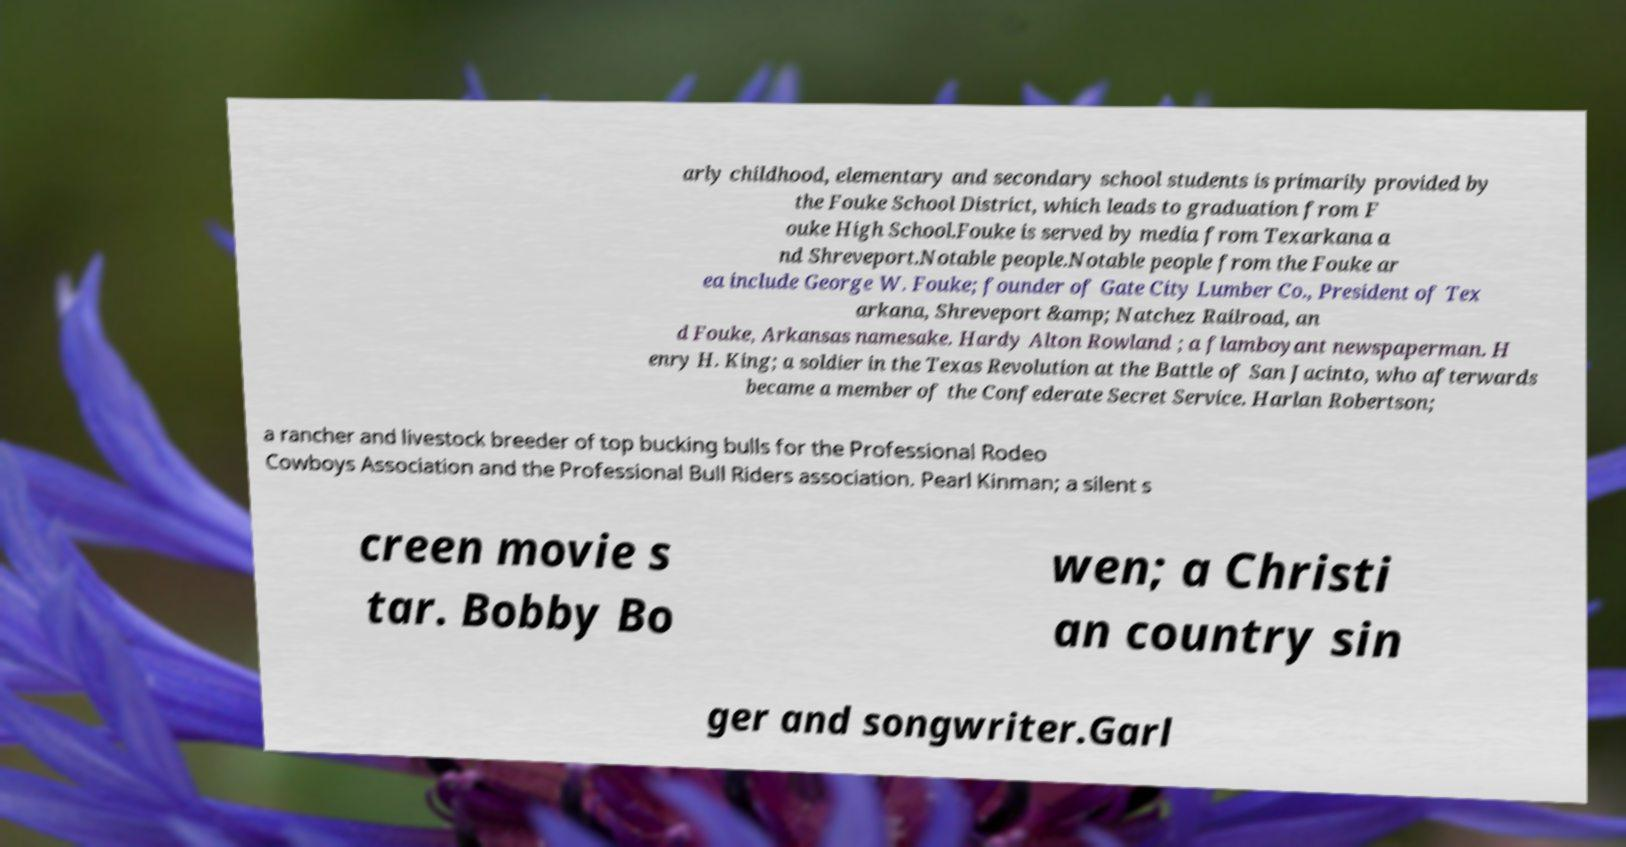Can you read and provide the text displayed in the image?This photo seems to have some interesting text. Can you extract and type it out for me? arly childhood, elementary and secondary school students is primarily provided by the Fouke School District, which leads to graduation from F ouke High School.Fouke is served by media from Texarkana a nd Shreveport.Notable people.Notable people from the Fouke ar ea include George W. Fouke; founder of Gate City Lumber Co., President of Tex arkana, Shreveport &amp; Natchez Railroad, an d Fouke, Arkansas namesake. Hardy Alton Rowland ; a flamboyant newspaperman. H enry H. King; a soldier in the Texas Revolution at the Battle of San Jacinto, who afterwards became a member of the Confederate Secret Service. Harlan Robertson; a rancher and livestock breeder of top bucking bulls for the Professional Rodeo Cowboys Association and the Professional Bull Riders association. Pearl Kinman; a silent s creen movie s tar. Bobby Bo wen; a Christi an country sin ger and songwriter.Garl 